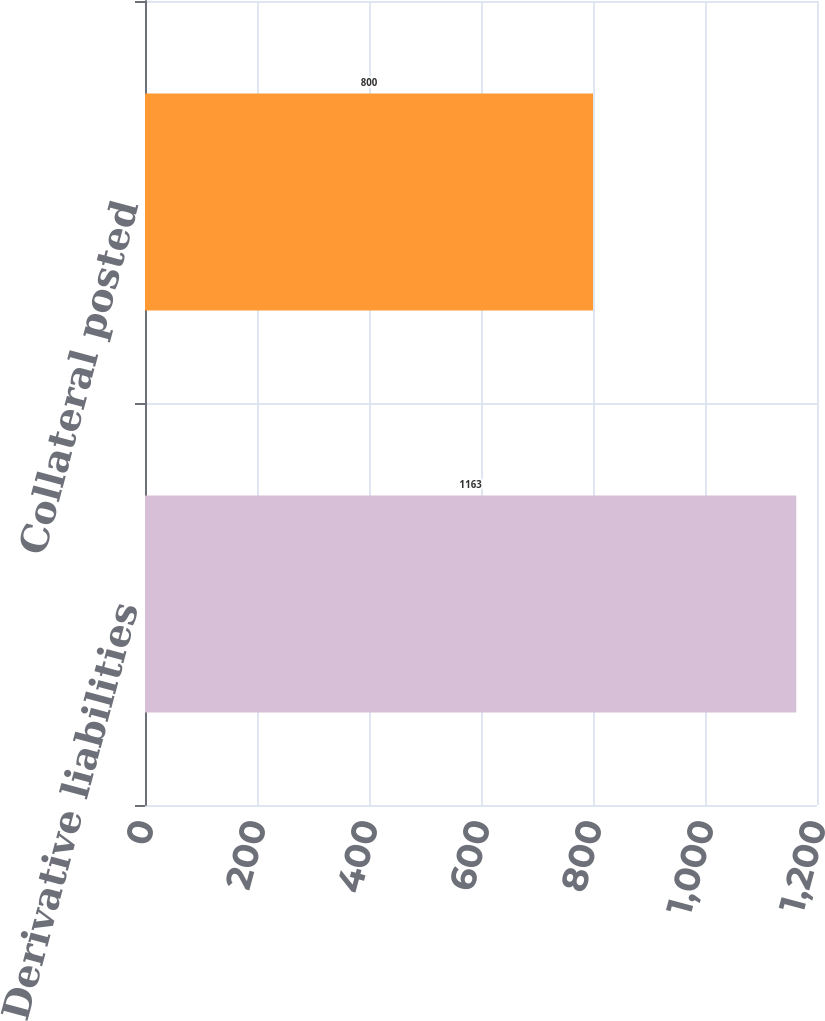Convert chart to OTSL. <chart><loc_0><loc_0><loc_500><loc_500><bar_chart><fcel>Derivative liabilities<fcel>Collateral posted<nl><fcel>1163<fcel>800<nl></chart> 